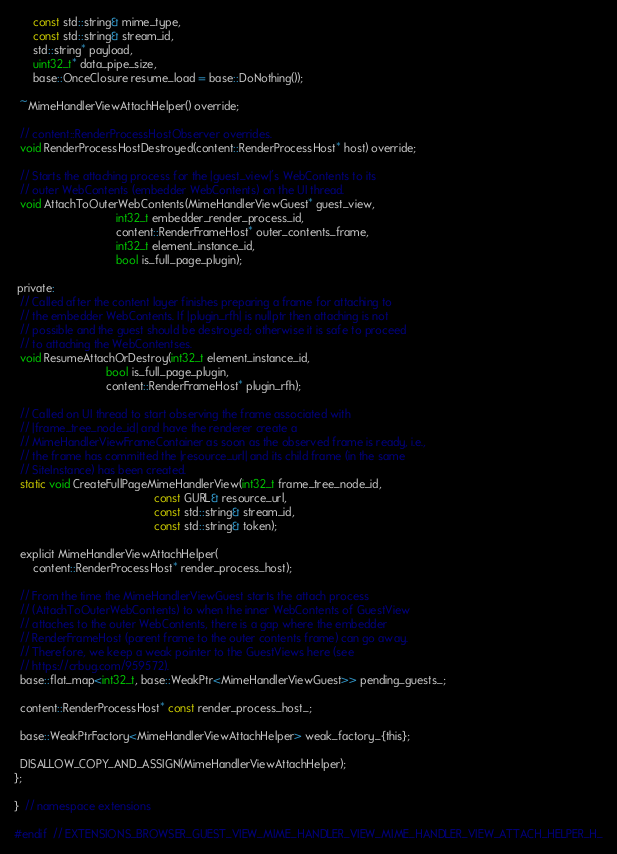<code> <loc_0><loc_0><loc_500><loc_500><_C_>      const std::string& mime_type,
      const std::string& stream_id,
      std::string* payload,
      uint32_t* data_pipe_size,
      base::OnceClosure resume_load = base::DoNothing());

  ~MimeHandlerViewAttachHelper() override;

  // content::RenderProcessHostObserver overrides.
  void RenderProcessHostDestroyed(content::RenderProcessHost* host) override;

  // Starts the attaching process for the |guest_view|'s WebContents to its
  // outer WebContents (embedder WebContents) on the UI thread.
  void AttachToOuterWebContents(MimeHandlerViewGuest* guest_view,
                                int32_t embedder_render_process_id,
                                content::RenderFrameHost* outer_contents_frame,
                                int32_t element_instance_id,
                                bool is_full_page_plugin);

 private:
  // Called after the content layer finishes preparing a frame for attaching to
  // the embedder WebContents. If |plugin_rfh| is nullptr then attaching is not
  // possible and the guest should be destroyed; otherwise it is safe to proceed
  // to attaching the WebContentses.
  void ResumeAttachOrDestroy(int32_t element_instance_id,
                             bool is_full_page_plugin,
                             content::RenderFrameHost* plugin_rfh);

  // Called on UI thread to start observing the frame associated with
  // |frame_tree_node_id| and have the renderer create a
  // MimeHandlerViewFrameContainer as soon as the observed frame is ready, i.e.,
  // the frame has committed the |resource_url| and its child frame (in the same
  // SiteInstance) has been created.
  static void CreateFullPageMimeHandlerView(int32_t frame_tree_node_id,
                                            const GURL& resource_url,
                                            const std::string& stream_id,
                                            const std::string& token);

  explicit MimeHandlerViewAttachHelper(
      content::RenderProcessHost* render_process_host);

  // From the time the MimeHandlerViewGuest starts the attach process
  // (AttachToOuterWebContents) to when the inner WebContents of GuestView
  // attaches to the outer WebContents, there is a gap where the embedder
  // RenderFrameHost (parent frame to the outer contents frame) can go away.
  // Therefore, we keep a weak pointer to the GuestViews here (see
  // https://crbug.com/959572).
  base::flat_map<int32_t, base::WeakPtr<MimeHandlerViewGuest>> pending_guests_;

  content::RenderProcessHost* const render_process_host_;

  base::WeakPtrFactory<MimeHandlerViewAttachHelper> weak_factory_{this};

  DISALLOW_COPY_AND_ASSIGN(MimeHandlerViewAttachHelper);
};

}  // namespace extensions

#endif  // EXTENSIONS_BROWSER_GUEST_VIEW_MIME_HANDLER_VIEW_MIME_HANDLER_VIEW_ATTACH_HELPER_H_
</code> 